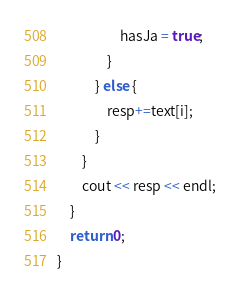<code> <loc_0><loc_0><loc_500><loc_500><_C++_>                    hasJa = true;
                }
            } else {
                resp+=text[i];
            }
        }
        cout << resp << endl;
    }
    return 0;
}
</code> 